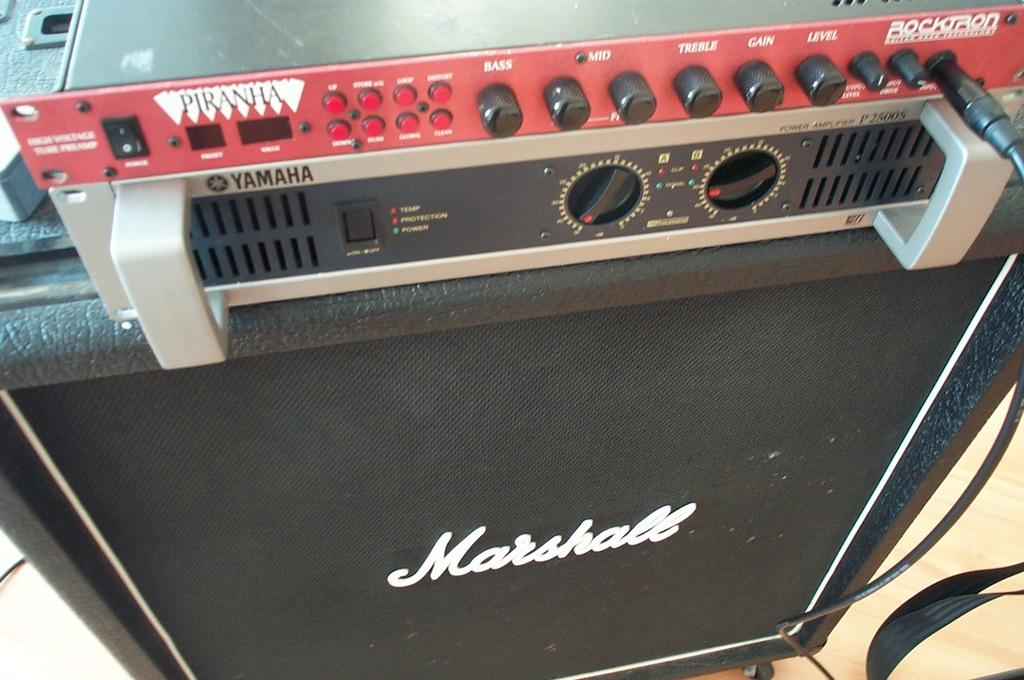<image>
Give a short and clear explanation of the subsequent image. A sub that says Marshall on the speaker. 